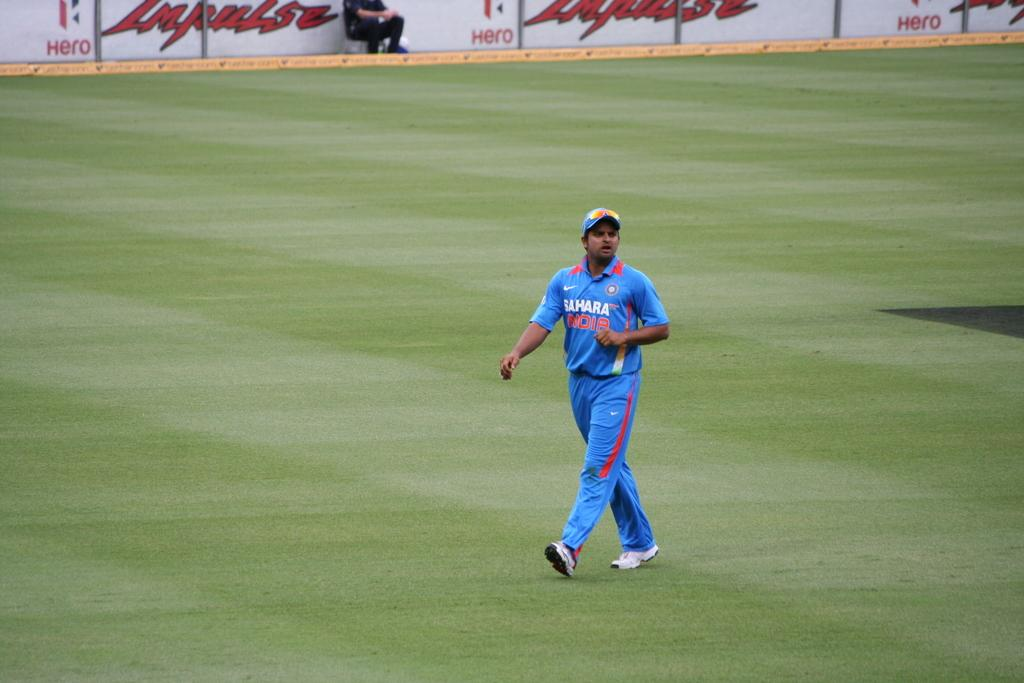<image>
Give a short and clear explanation of the subsequent image. A man walks across an empty sports field wearing a Sahara India uniform. 